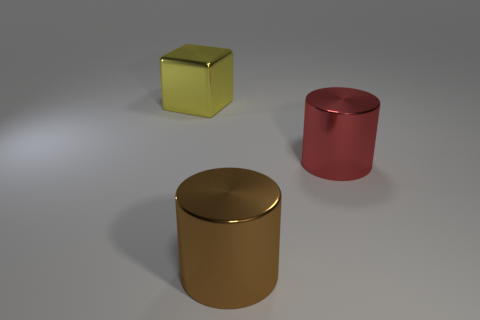There is another large object that is the same shape as the big red metallic object; what color is it?
Keep it short and to the point. Brown. There is a large shiny thing behind the large red metallic object; what shape is it?
Offer a very short reply. Cube. There is a brown thing; are there any large metallic cylinders behind it?
Your answer should be very brief. Yes. Is there anything else that is the same size as the red shiny cylinder?
Offer a very short reply. Yes. The big cube that is the same material as the red cylinder is what color?
Provide a succinct answer. Yellow. There is a metallic thing on the left side of the brown shiny cylinder; is it the same color as the cylinder in front of the red cylinder?
Ensure brevity in your answer.  No. How many cylinders are either small gray rubber objects or large things?
Provide a short and direct response. 2. Is the number of big red cylinders in front of the red shiny cylinder the same as the number of blue matte cylinders?
Your answer should be very brief. Yes. The large thing right of the shiny cylinder that is in front of the large cylinder that is to the right of the brown metallic thing is made of what material?
Make the answer very short. Metal. How many objects are big shiny things on the right side of the large yellow shiny cube or large yellow shiny objects?
Make the answer very short. 3. 